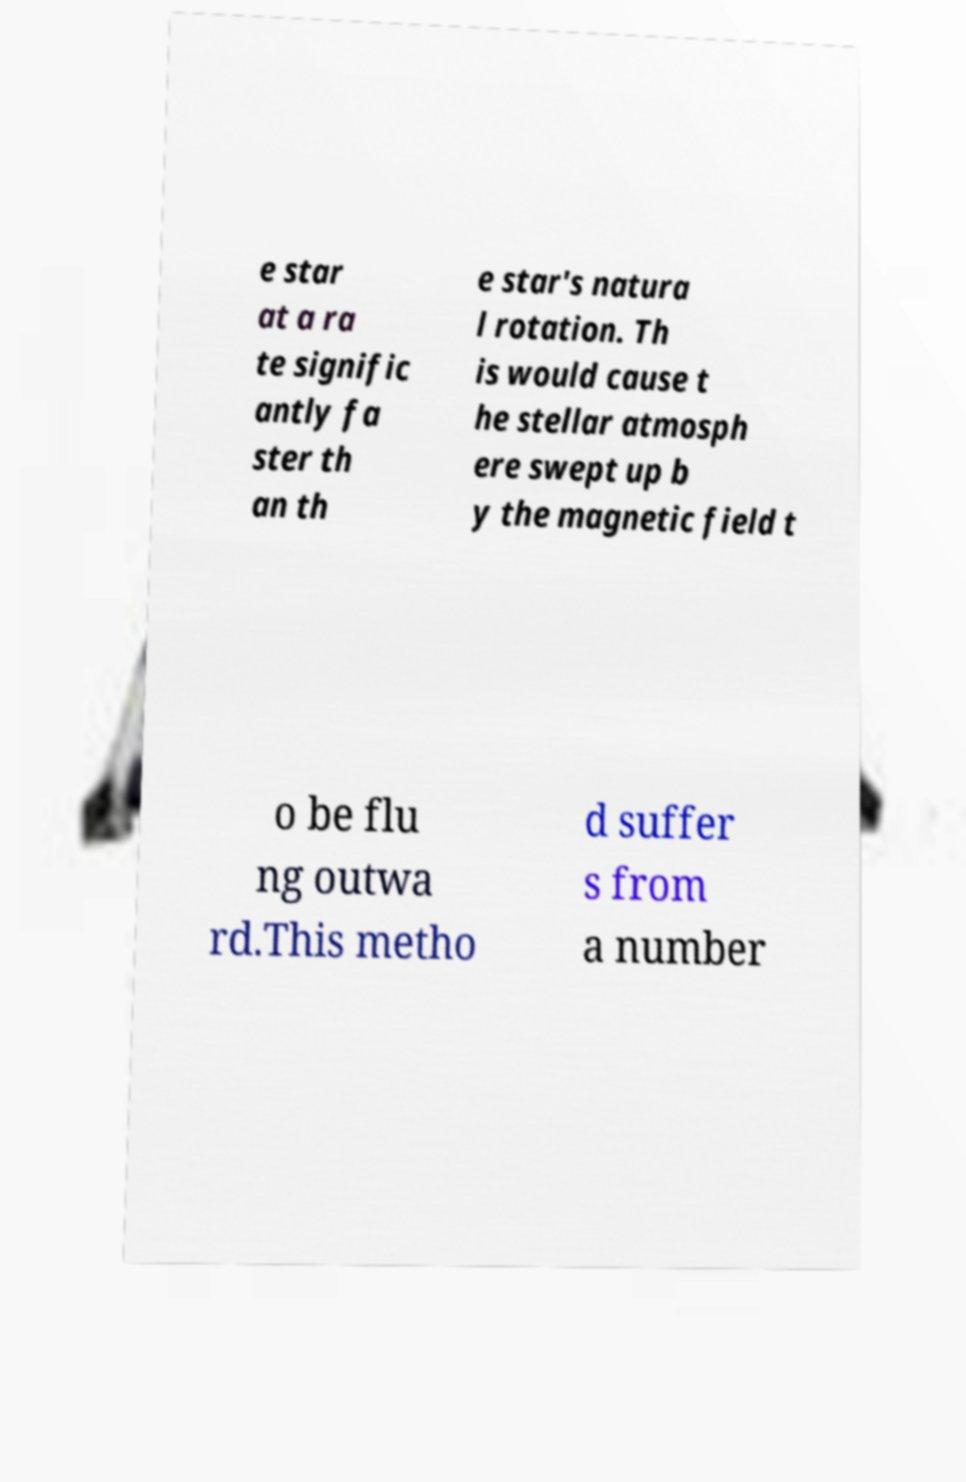Can you read and provide the text displayed in the image?This photo seems to have some interesting text. Can you extract and type it out for me? e star at a ra te signific antly fa ster th an th e star's natura l rotation. Th is would cause t he stellar atmosph ere swept up b y the magnetic field t o be flu ng outwa rd.This metho d suffer s from a number 